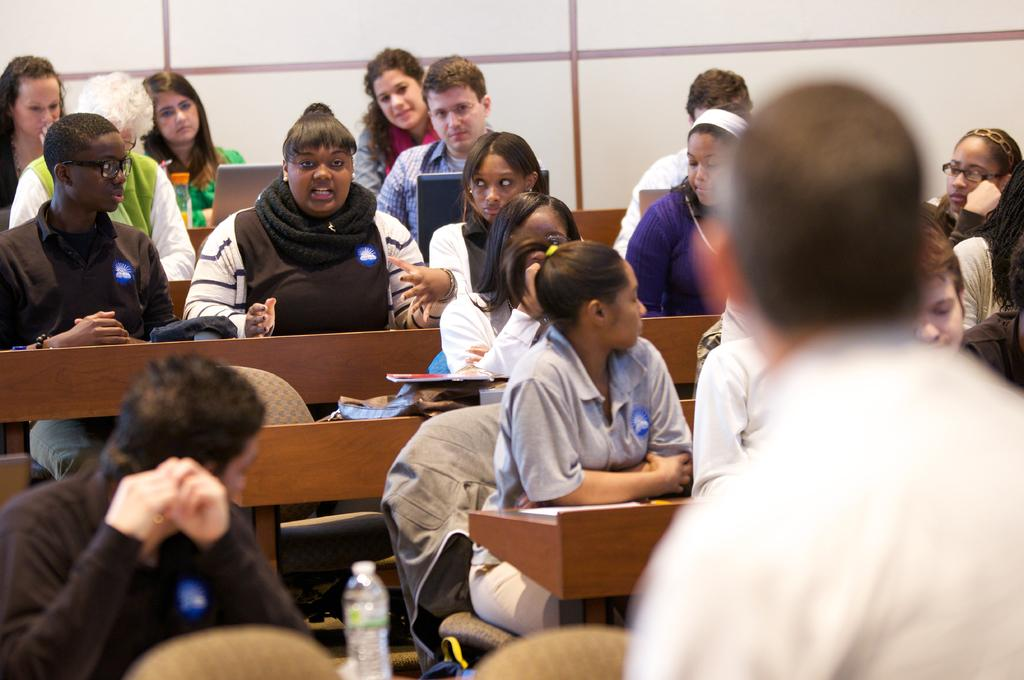What are the people in the image doing? There are persons sitting on a bench in the image, and one girl is talking while others are watching. What object can be seen in the image besides the people? There is a bottle in the image. What is the color of the background in the image? The background of the image is white. What type of history can be seen in the image? There is no history present in the image; it features people sitting on a bench and a bottle. Can you tell me how many sheets are visible in the image? There are no sheets present in the image. 